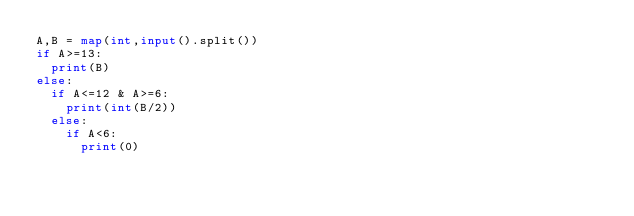Convert code to text. <code><loc_0><loc_0><loc_500><loc_500><_Python_>A,B = map(int,input().split())
if A>=13:
	print(B)
else:
	if A<=12 & A>=6:
		print(int(B/2))
	else:
		if A<6:
			print(0)</code> 